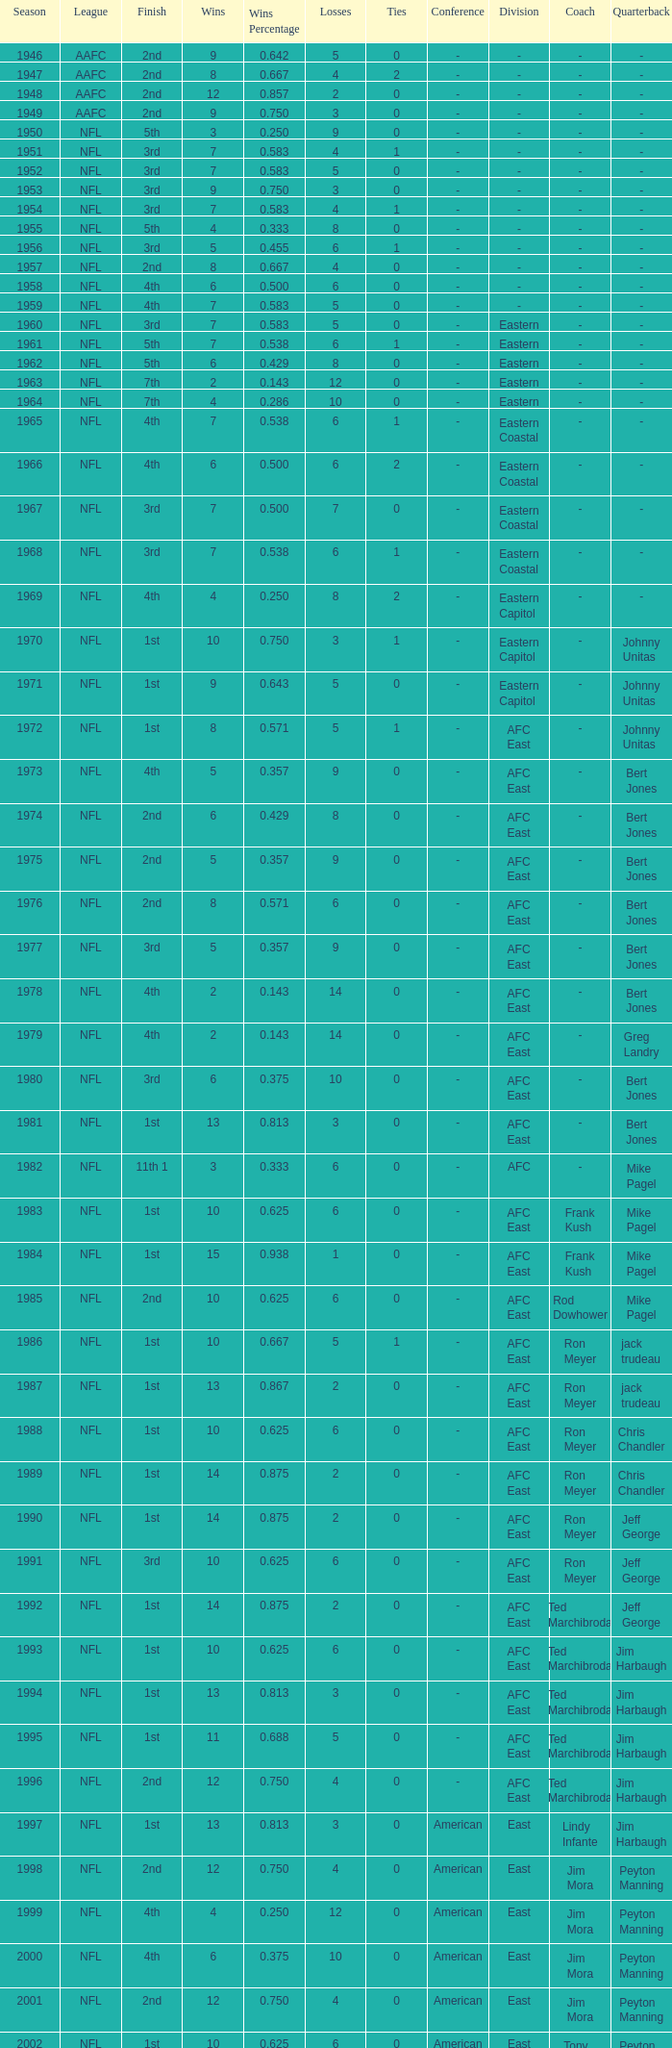What is the lowest number of ties in the NFL, with less than 2 losses and less than 15 wins? None. I'm looking to parse the entire table for insights. Could you assist me with that? {'header': ['Season', 'League', 'Finish', 'Wins', 'Wins Percentage', 'Losses', 'Ties', 'Conference', 'Division', 'Coach', 'Quarterback'], 'rows': [['1946', 'AAFC', '2nd', '9', '0.642', '5', '0', '-', '-', '-', '-'], ['1947', 'AAFC', '2nd', '8', '0.667', '4', '2', '-', '-', '-', '-'], ['1948', 'AAFC', '2nd', '12', '0.857', '2', '0', '-', '-', '-', '-'], ['1949', 'AAFC', '2nd', '9', '0.750', '3', '0', '-', '-', '-', '-'], ['1950', 'NFL', '5th', '3', '0.250', '9', '0', '-', '-', '-', '-'], ['1951', 'NFL', '3rd', '7', '0.583', '4', '1', '-', '-', '-', '-'], ['1952', 'NFL', '3rd', '7', '0.583', '5', '0', '-', '-', '-', '-'], ['1953', 'NFL', '3rd', '9', '0.750', '3', '0', '-', '-', '-', '-'], ['1954', 'NFL', '3rd', '7', '0.583', '4', '1', '-', '-', '-', '-'], ['1955', 'NFL', '5th', '4', '0.333', '8', '0', '-', '-', '-', '-'], ['1956', 'NFL', '3rd', '5', '0.455', '6', '1', '-', '-', '-', '-'], ['1957', 'NFL', '2nd', '8', '0.667', '4', '0', '-', '-', '-', '-'], ['1958', 'NFL', '4th', '6', '0.500', '6', '0', '-', '-', '-', '-'], ['1959', 'NFL', '4th', '7', '0.583', '5', '0', '-', '-', '-', '-'], ['1960', 'NFL', '3rd', '7', '0.583', '5', '0', '-', 'Eastern', '-', '-'], ['1961', 'NFL', '5th', '7', '0.538', '6', '1', '-', 'Eastern', '-', '-'], ['1962', 'NFL', '5th', '6', '0.429', '8', '0', '-', 'Eastern', '-', '-'], ['1963', 'NFL', '7th', '2', '0.143', '12', '0', '-', 'Eastern', '-', '-'], ['1964', 'NFL', '7th', '4', '0.286', '10', '0', '-', 'Eastern', '-', '-'], ['1965', 'NFL', '4th', '7', '0.538', '6', '1', '-', 'Eastern Coastal', '-', '-'], ['1966', 'NFL', '4th', '6', '0.500', '6', '2', '-', 'Eastern Coastal', '-', '-'], ['1967', 'NFL', '3rd', '7', '0.500', '7', '0', '-', 'Eastern Coastal', '-', '-'], ['1968', 'NFL', '3rd', '7', '0.538', '6', '1', '-', 'Eastern Coastal', '-', '-'], ['1969', 'NFL', '4th', '4', '0.250', '8', '2', '-', 'Eastern Capitol', '-', '-'], ['1970', 'NFL', '1st', '10', '0.750', '3', '1', '-', 'Eastern Capitol', '-', 'Johnny Unitas'], ['1971', 'NFL', '1st', '9', '0.643', '5', '0', '-', 'Eastern Capitol', '-', 'Johnny Unitas'], ['1972', 'NFL', '1st', '8', '0.571', '5', '1', '-', 'AFC East', '-', 'Johnny Unitas'], ['1973', 'NFL', '4th', '5', '0.357', '9', '0', '-', 'AFC East', '-', 'Bert Jones'], ['1974', 'NFL', '2nd', '6', '0.429', '8', '0', '-', 'AFC East', '-', 'Bert Jones'], ['1975', 'NFL', '2nd', '5', '0.357', '9', '0', '-', 'AFC East', '-', 'Bert Jones'], ['1976', 'NFL', '2nd', '8', '0.571', '6', '0', '-', 'AFC East', '-', 'Bert Jones'], ['1977', 'NFL', '3rd', '5', '0.357', '9', '0', '-', 'AFC East', '-', 'Bert Jones'], ['1978', 'NFL', '4th', '2', '0.143', '14', '0', '-', 'AFC East', '-', 'Bert Jones'], ['1979', 'NFL', '4th', '2', '0.143', '14', '0', '-', 'AFC East', '-', 'Greg Landry'], ['1980', 'NFL', '3rd', '6', '0.375', '10', '0', '-', 'AFC East', '-', 'Bert Jones'], ['1981', 'NFL', '1st', '13', '0.813', '3', '0', '-', 'AFC East', '-', 'Bert Jones'], ['1982', 'NFL', '11th 1', '3', '0.333', '6', '0', '-', 'AFC', '-', 'Mike Pagel'], ['1983', 'NFL', '1st', '10', '0.625', '6', '0', '-', 'AFC East', 'Frank Kush', 'Mike Pagel'], ['1984', 'NFL', '1st', '15', '0.938', '1', '0', '-', 'AFC East', 'Frank Kush', 'Mike Pagel'], ['1985', 'NFL', '2nd', '10', '0.625', '6', '0', '-', 'AFC East', 'Rod Dowhower', 'Mike Pagel'], ['1986', 'NFL', '1st', '10', '0.667', '5', '1', '-', 'AFC East', 'Ron Meyer', 'jack trudeau'], ['1987', 'NFL', '1st', '13', '0.867', '2', '0', '-', 'AFC East', 'Ron Meyer', 'jack trudeau'], ['1988', 'NFL', '1st', '10', '0.625', '6', '0', '-', 'AFC East', 'Ron Meyer', 'Chris Chandler'], ['1989', 'NFL', '1st', '14', '0.875', '2', '0', '-', 'AFC East', 'Ron Meyer', 'Chris Chandler'], ['1990', 'NFL', '1st', '14', '0.875', '2', '0', '-', 'AFC East', 'Ron Meyer', 'Jeff George'], ['1991', 'NFL', '3rd', '10', '0.625', '6', '0', '-', 'AFC East', 'Ron Meyer', 'Jeff George'], ['1992', 'NFL', '1st', '14', '0.875', '2', '0', '-', 'AFC East', 'Ted Marchibroda', 'Jeff George'], ['1993', 'NFL', '1st', '10', '0.625', '6', '0', '-', 'AFC East', 'Ted Marchibroda', 'Jim Harbaugh'], ['1994', 'NFL', '1st', '13', '0.813', '3', '0', '-', 'AFC East', 'Ted Marchibroda', 'Jim Harbaugh'], ['1995', 'NFL', '1st', '11', '0.688', '5', '0', '-', 'AFC East', 'Ted Marchibroda', 'Jim Harbaugh'], ['1996', 'NFL', '2nd', '12', '0.750', '4', '0', '-', 'AFC East', 'Ted Marchibroda', 'Jim Harbaugh'], ['1997', 'NFL', '1st', '13', '0.813', '3', '0', 'American', 'East', 'Lindy Infante', 'Jim Harbaugh'], ['1998', 'NFL', '2nd', '12', '0.750', '4', '0', 'American', 'East', 'Jim Mora', 'Peyton Manning'], ['1999', 'NFL', '4th', '4', '0.250', '12', '0', 'American', 'East', 'Jim Mora', 'Peyton Manning'], ['2000', 'NFL', '4th', '6', '0.375', '10', '0', 'American', 'East', 'Jim Mora', 'Peyton Manning'], ['2001', 'NFL', '2nd', '12', '0.750', '4', '0', 'American', 'East', 'Jim Mora', 'Peyton Manning'], ['2002', 'NFL', '1st', '10', '0.625', '6', '0', 'American', 'East', 'Tony Dungy', 'Peyton Manning'], ['2003', 'NFL', '3rd', '7', '0.438', '9', '0', 'American', 'South', 'Tony Dungy', 'Peyton Manning'], ['2004', 'NFL', '4th', '2', '0.125', '14', '0', 'American', 'South', 'Tony Dungy', 'Peyton Manning'], ['2005', 'NFL', '4th', '4', '0.250', '12', '0', 'American', 'South', 'Tony Dungy', 'Peyton Manning'], ['2006', 'NFL', '3rd', '7', '0.438', '9', '0', 'American', 'South', 'Tony Dungy', 'Peyton Manning'], ['2007', 'NFL', '3rd', '5', '0.313', '11', '0', 'AFC', 'South', 'Tony Dungy', 'Peyton Manning'], ['2008', 'NFL', '2nd', '7', '0.438', '9', '0', 'AFC', 'South', 'Tony Dungy', 'Peyton Manning'], ['2009', 'NFL', '2nd', '8', '0.500', '8', '0', 'AFC', 'South', 'Jim Caldwell', 'Peyton Manning'], ['2010', 'NFL', '3rd', '6', '0.375', '10', '0', 'AFC', 'South', 'Jim Caldwell', 'Peyton Manning'], ['2011', 'NFL', '1st', '13', '0.813', '3', '0', 'AFC', 'South', 'Jim Caldwell', 'Peyton Manning'], ['2012', 'NFL', '1st', '11', '0.719', '4', '1', 'AFC', 'South', 'Chuck Pagano', 'Andrew Luck'], ['2013', 'NFL', '2nd', '6', '0.750', '2', '0', 'AFC', 'South', 'Chuck Pagano', 'Andrew Luck']]} 